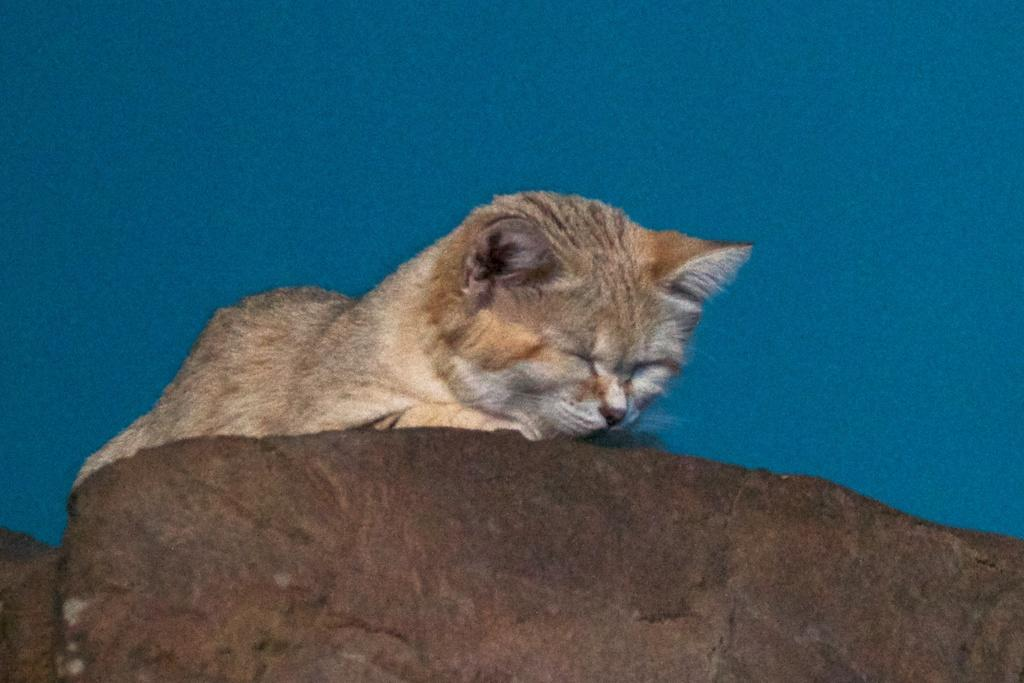What color is the backdrop in the image? The backdrop in the image is blue. What animal can be seen in the image? There is a cat in the image. What is the color of the surface at the bottom portion of the image? The surface at the bottom portion of the image is brown. What type of skin condition does the cat have in the image? There is no indication of a skin condition in the image; the cat appears to have normal fur. Can you tell me how many horses are present in the image? There are no horses present in the image; it features a cat and a blue backdrop. 